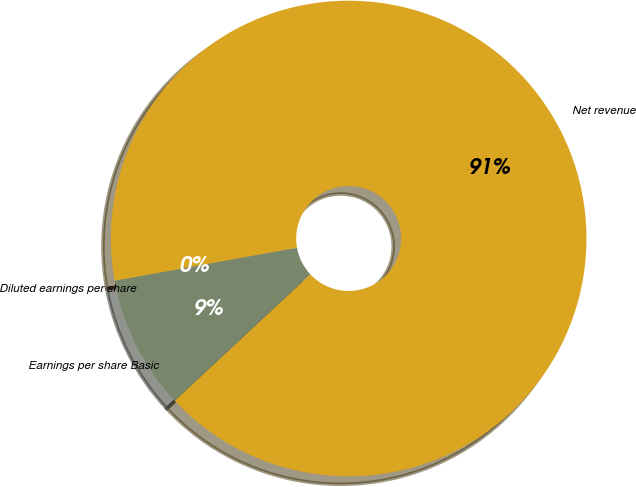Convert chart. <chart><loc_0><loc_0><loc_500><loc_500><pie_chart><fcel>Net revenue<fcel>Earnings per share Basic<fcel>Diluted earnings per share<nl><fcel>90.91%<fcel>9.09%<fcel>0.0%<nl></chart> 